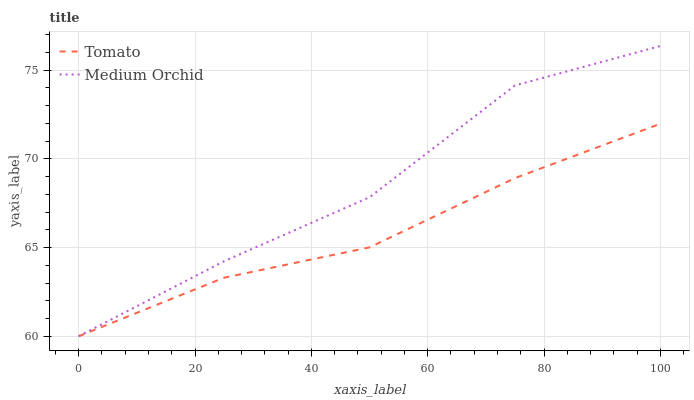Does Tomato have the minimum area under the curve?
Answer yes or no. Yes. Does Medium Orchid have the maximum area under the curve?
Answer yes or no. Yes. Does Medium Orchid have the minimum area under the curve?
Answer yes or no. No. Is Tomato the smoothest?
Answer yes or no. Yes. Is Medium Orchid the roughest?
Answer yes or no. Yes. Is Medium Orchid the smoothest?
Answer yes or no. No. Does Tomato have the lowest value?
Answer yes or no. Yes. Does Medium Orchid have the highest value?
Answer yes or no. Yes. Does Tomato intersect Medium Orchid?
Answer yes or no. Yes. Is Tomato less than Medium Orchid?
Answer yes or no. No. Is Tomato greater than Medium Orchid?
Answer yes or no. No. 